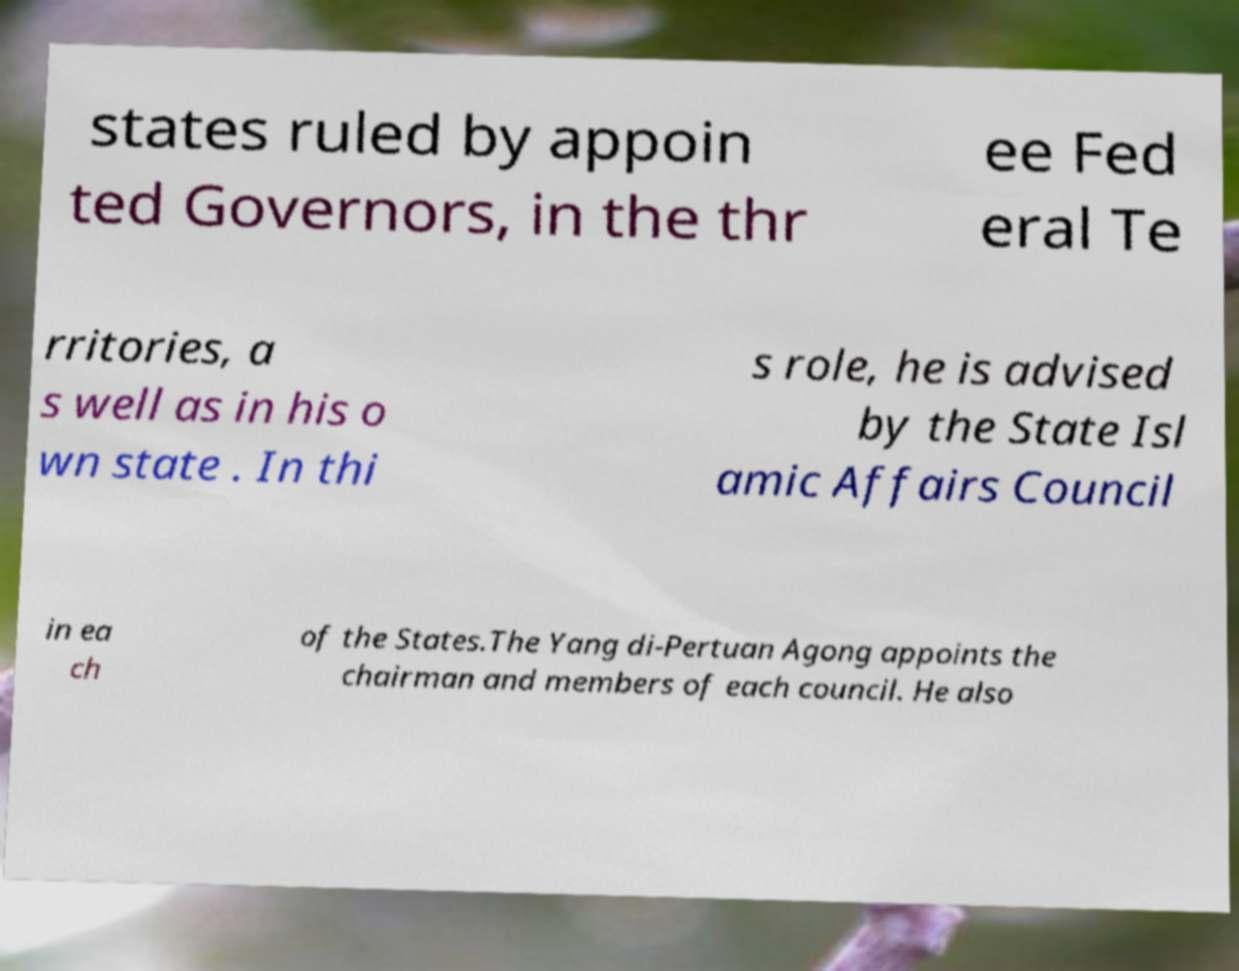Can you accurately transcribe the text from the provided image for me? states ruled by appoin ted Governors, in the thr ee Fed eral Te rritories, a s well as in his o wn state . In thi s role, he is advised by the State Isl amic Affairs Council in ea ch of the States.The Yang di-Pertuan Agong appoints the chairman and members of each council. He also 